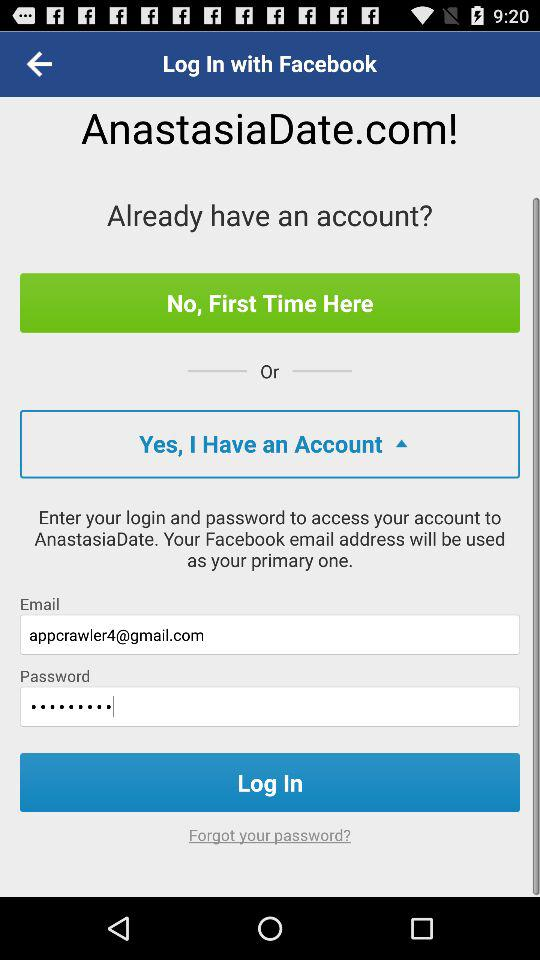What social email address will be used as your primary one? The social email address that will be used as your primary one is "Facebook". 